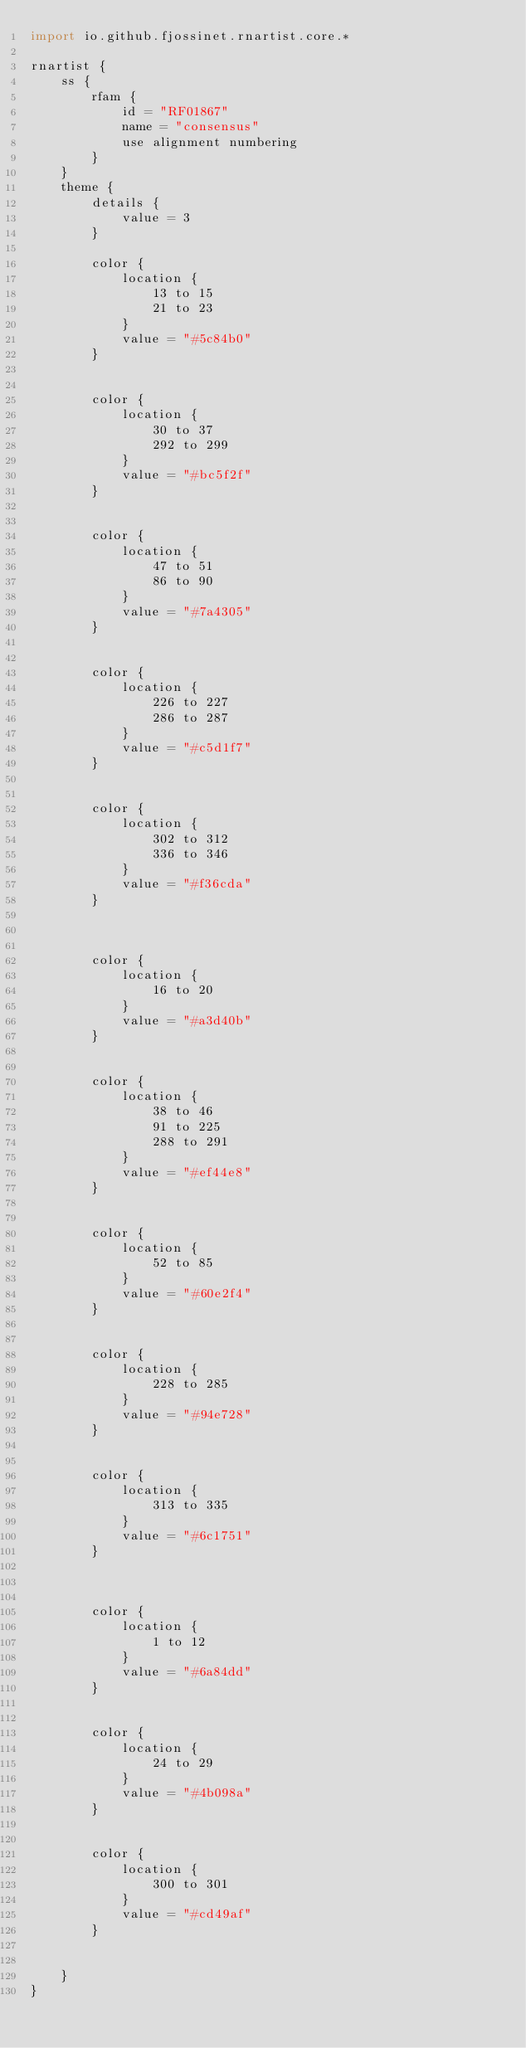Convert code to text. <code><loc_0><loc_0><loc_500><loc_500><_Kotlin_>import io.github.fjossinet.rnartist.core.*      

rnartist {
    ss {
        rfam {
            id = "RF01867"
            name = "consensus"
            use alignment numbering
        }
    }
    theme {
        details { 
            value = 3
        }

        color {
            location {
                13 to 15
                21 to 23
            }
            value = "#5c84b0"
        }


        color {
            location {
                30 to 37
                292 to 299
            }
            value = "#bc5f2f"
        }


        color {
            location {
                47 to 51
                86 to 90
            }
            value = "#7a4305"
        }


        color {
            location {
                226 to 227
                286 to 287
            }
            value = "#c5d1f7"
        }


        color {
            location {
                302 to 312
                336 to 346
            }
            value = "#f36cda"
        }



        color {
            location {
                16 to 20
            }
            value = "#a3d40b"
        }


        color {
            location {
                38 to 46
                91 to 225
                288 to 291
            }
            value = "#ef44e8"
        }


        color {
            location {
                52 to 85
            }
            value = "#60e2f4"
        }


        color {
            location {
                228 to 285
            }
            value = "#94e728"
        }


        color {
            location {
                313 to 335
            }
            value = "#6c1751"
        }



        color {
            location {
                1 to 12
            }
            value = "#6a84dd"
        }


        color {
            location {
                24 to 29
            }
            value = "#4b098a"
        }


        color {
            location {
                300 to 301
            }
            value = "#cd49af"
        }


    }
}           </code> 